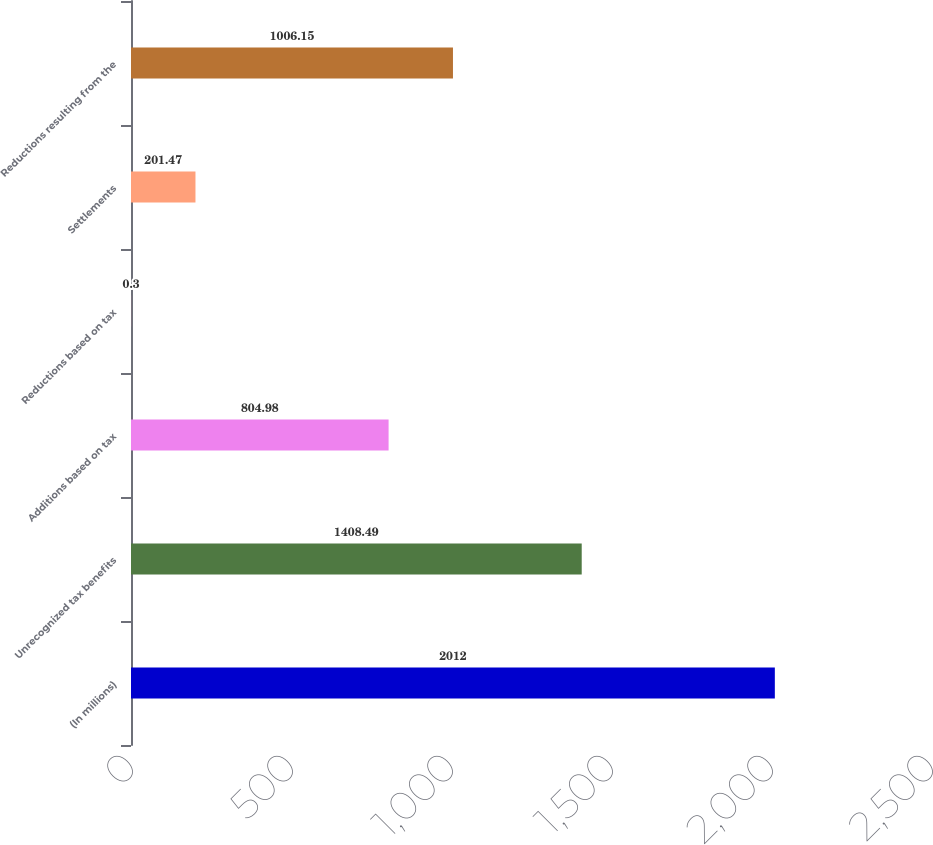Convert chart to OTSL. <chart><loc_0><loc_0><loc_500><loc_500><bar_chart><fcel>(In millions)<fcel>Unrecognized tax benefits<fcel>Additions based on tax<fcel>Reductions based on tax<fcel>Settlements<fcel>Reductions resulting from the<nl><fcel>2012<fcel>1408.49<fcel>804.98<fcel>0.3<fcel>201.47<fcel>1006.15<nl></chart> 